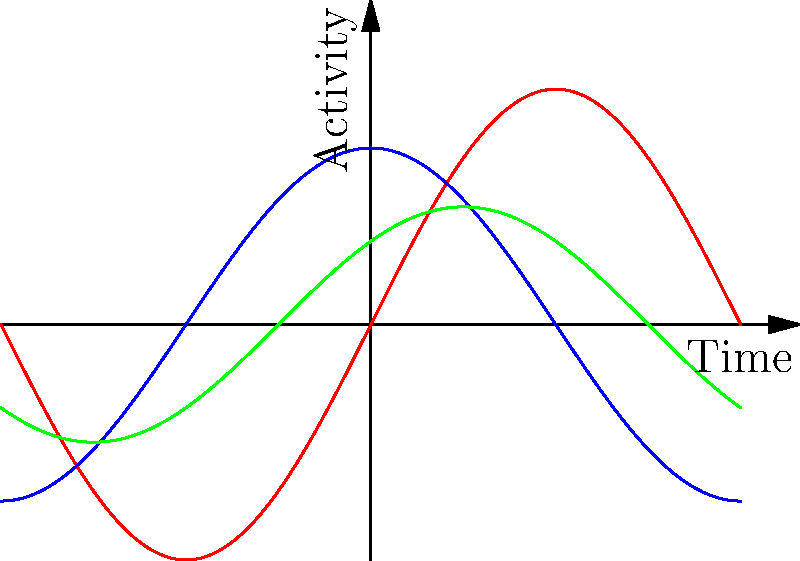The graph shows brain activity patterns in response to different sensory inputs over time. If we consider these patterns as elements of a group under rotation, what is the order of the rotation that transforms the visual input pattern (red) into the tactile input pattern (green)? To solve this problem, we need to follow these steps:

1. Observe the patterns:
   - Visual (red): $f(x) = 2\sin(x)$
   - Auditory (blue): $g(x) = 1.5\cos(x)$
   - Tactile (green): $h(x) = \sin(x+\frac{\pi}{4})$

2. Focus on the visual and tactile patterns:
   - Visual: $f(x) = 2\sin(x)$
   - Tactile: $h(x) = \sin(x+\frac{\pi}{4})$

3. Identify the transformation:
   - The tactile pattern is a shifted and scaled version of the visual pattern.
   - The shift is $\frac{\pi}{4}$ to the left.
   - The scale factor is $\frac{1}{2}$.

4. Consider rotations in the group theory context:
   - A full rotation is $2\pi$.
   - The shift of $\frac{\pi}{4}$ represents a fraction of a full rotation.

5. Calculate the order of rotation:
   - Order = $\frac{\text{Full rotation}}{\text{Observed rotation}} = \frac{2\pi}{\frac{\pi}{4}} = 8$

Therefore, the order of the rotation that transforms the visual input pattern into the tactile input pattern is 8.
Answer: 8 